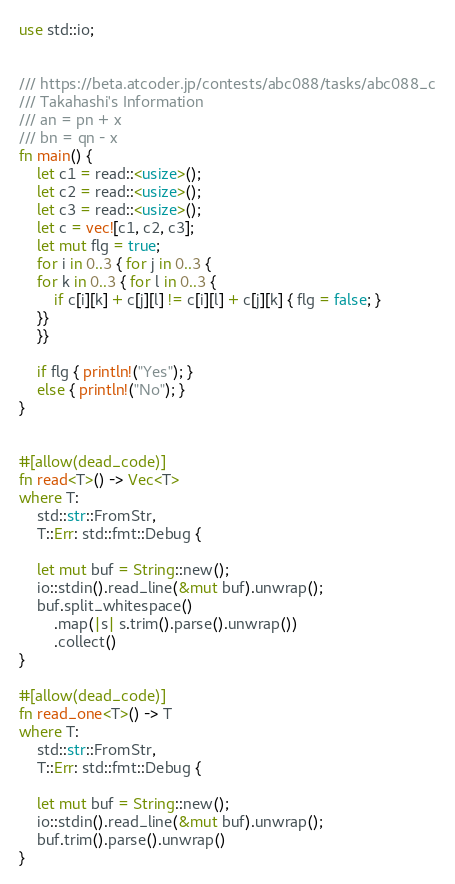<code> <loc_0><loc_0><loc_500><loc_500><_Rust_>use std::io;


/// https://beta.atcoder.jp/contests/abc088/tasks/abc088_c
/// Takahashi's Information
/// an = pn + x
/// bn = qn - x
fn main() {
    let c1 = read::<usize>();
    let c2 = read::<usize>();
    let c3 = read::<usize>();
    let c = vec![c1, c2, c3];
    let mut flg = true;
    for i in 0..3 { for j in 0..3 {
    for k in 0..3 { for l in 0..3 {
        if c[i][k] + c[j][l] != c[i][l] + c[j][k] { flg = false; }
    }}
    }}

    if flg { println!("Yes"); }
    else { println!("No"); }
}


#[allow(dead_code)]
fn read<T>() -> Vec<T>
where T:
    std::str::FromStr,
    T::Err: std::fmt::Debug {

    let mut buf = String::new();
    io::stdin().read_line(&mut buf).unwrap();
    buf.split_whitespace()
        .map(|s| s.trim().parse().unwrap())
        .collect()
}

#[allow(dead_code)]
fn read_one<T>() -> T
where T:
    std::str::FromStr,
    T::Err: std::fmt::Debug {

    let mut buf = String::new();
    io::stdin().read_line(&mut buf).unwrap();
    buf.trim().parse().unwrap()
}</code> 